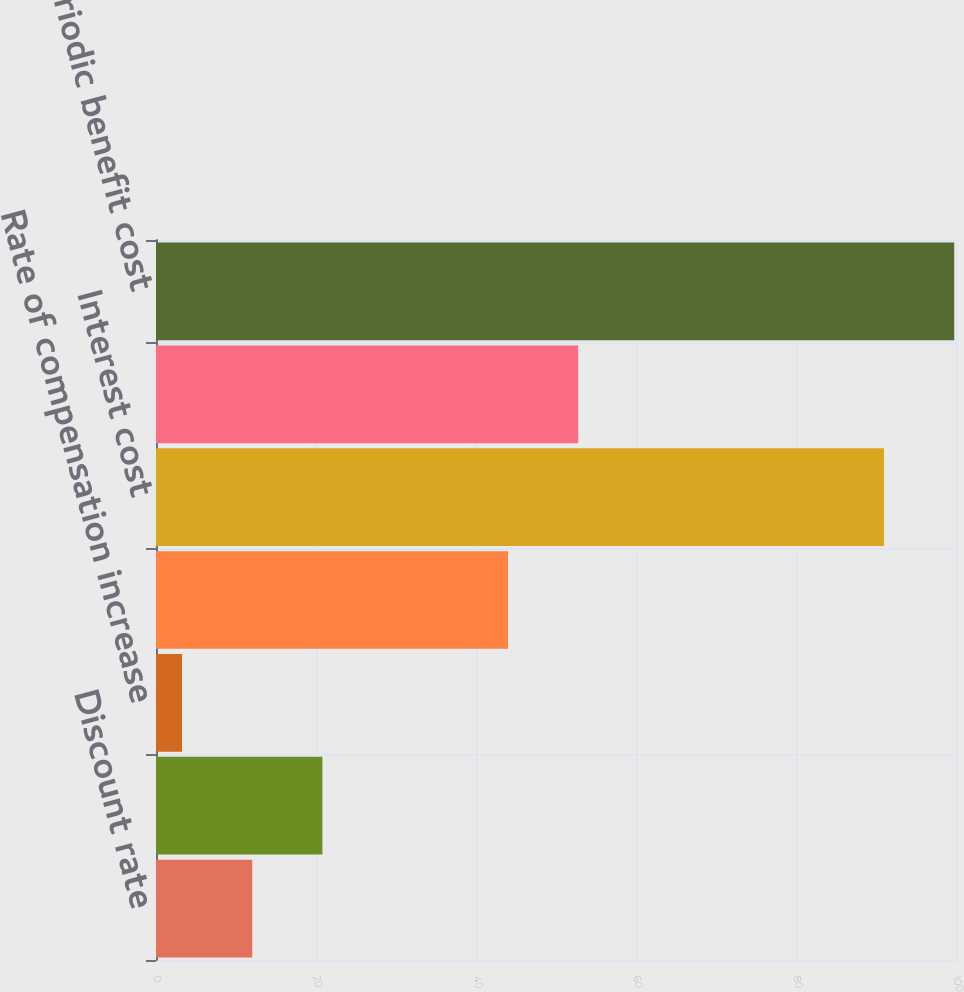Convert chart to OTSL. <chart><loc_0><loc_0><loc_500><loc_500><bar_chart><fcel>Discount rate<fcel>Expected return on plan assets<fcel>Rate of compensation increase<fcel>Service cost<fcel>Interest cost<fcel>Amortization of net actuarial<fcel>Net periodic benefit cost<nl><fcel>12.03<fcel>20.8<fcel>3.25<fcel>44<fcel>91<fcel>52.77<fcel>99.78<nl></chart> 